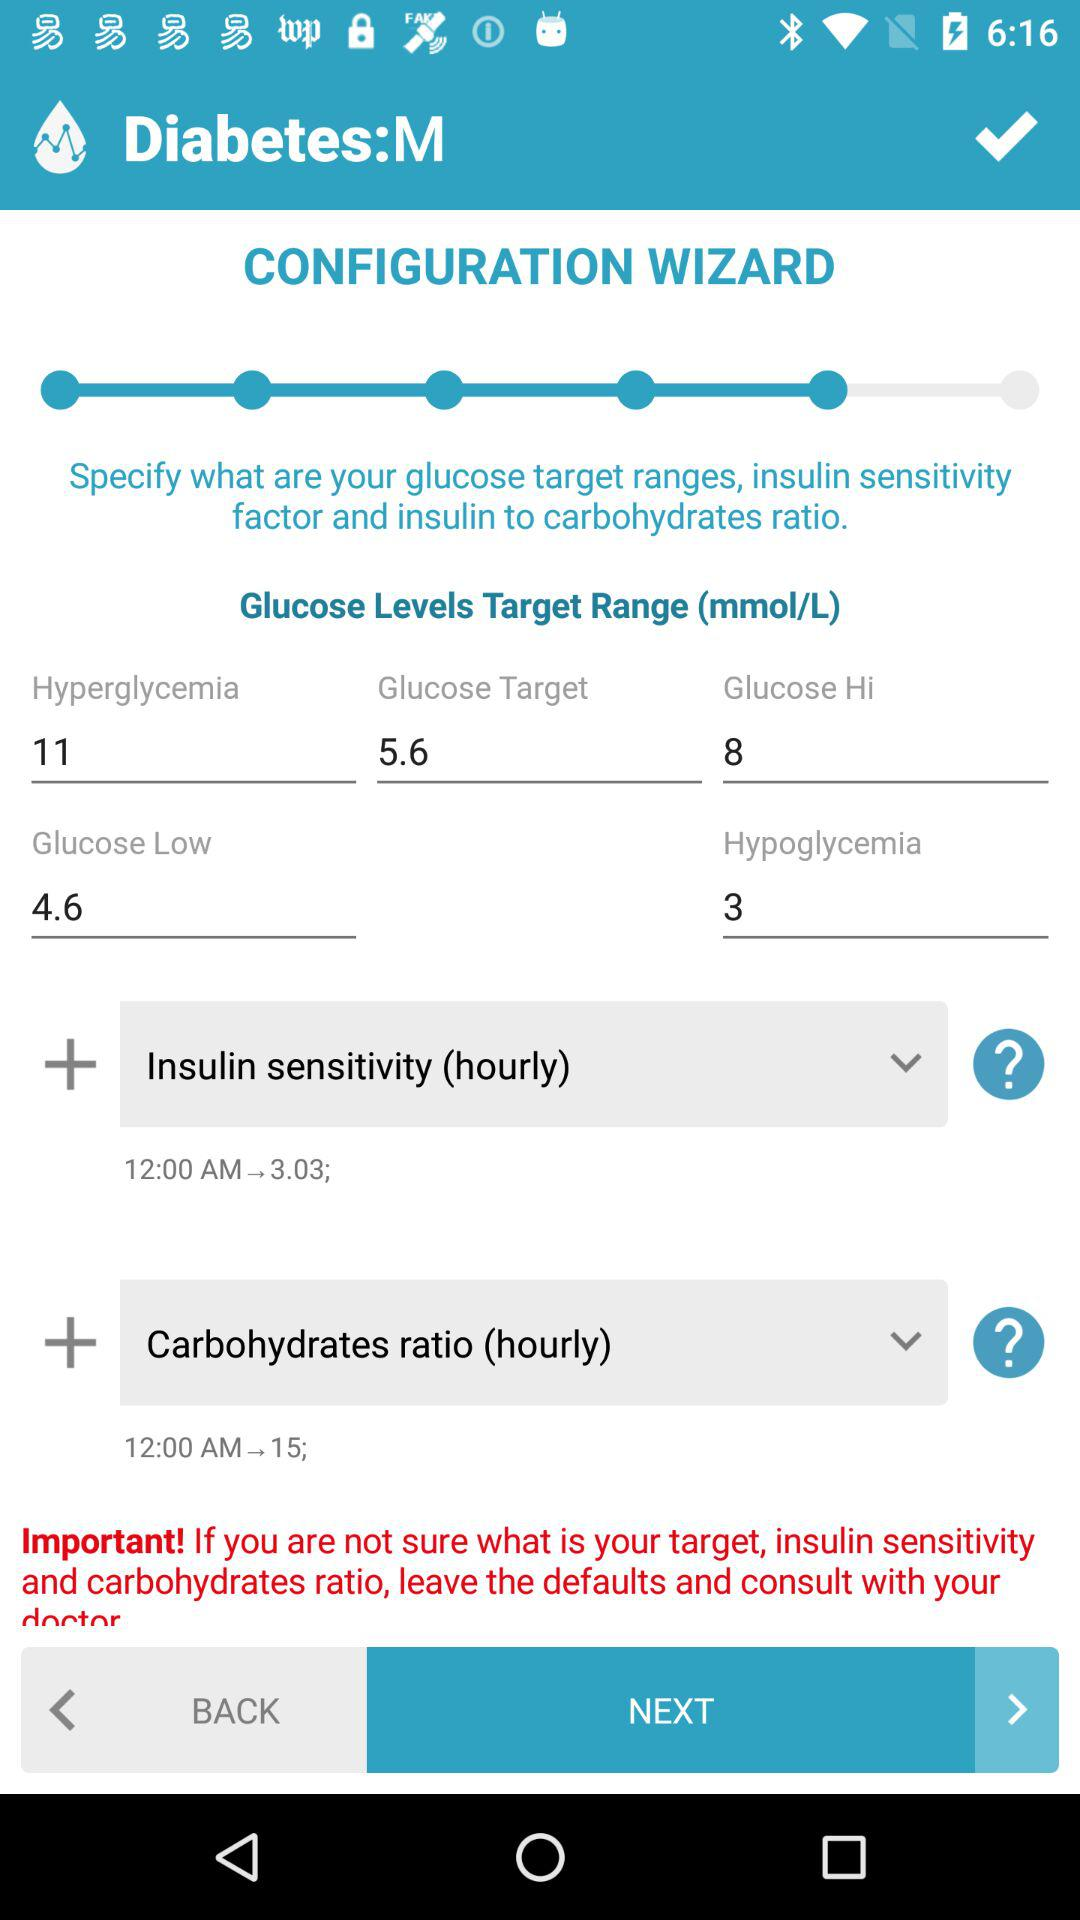What is the low glucose value? The low glucose value is 4.6. 